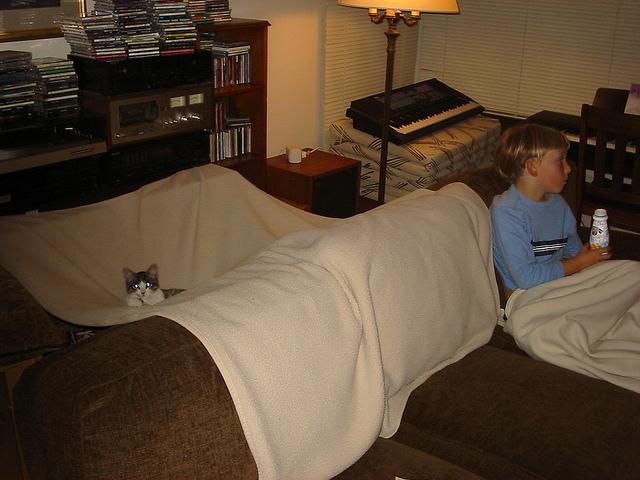How many kids are there?
Give a very brief answer. 1. How many dogs are there?
Give a very brief answer. 0. How many kids are in the picture?
Give a very brief answer. 1. 